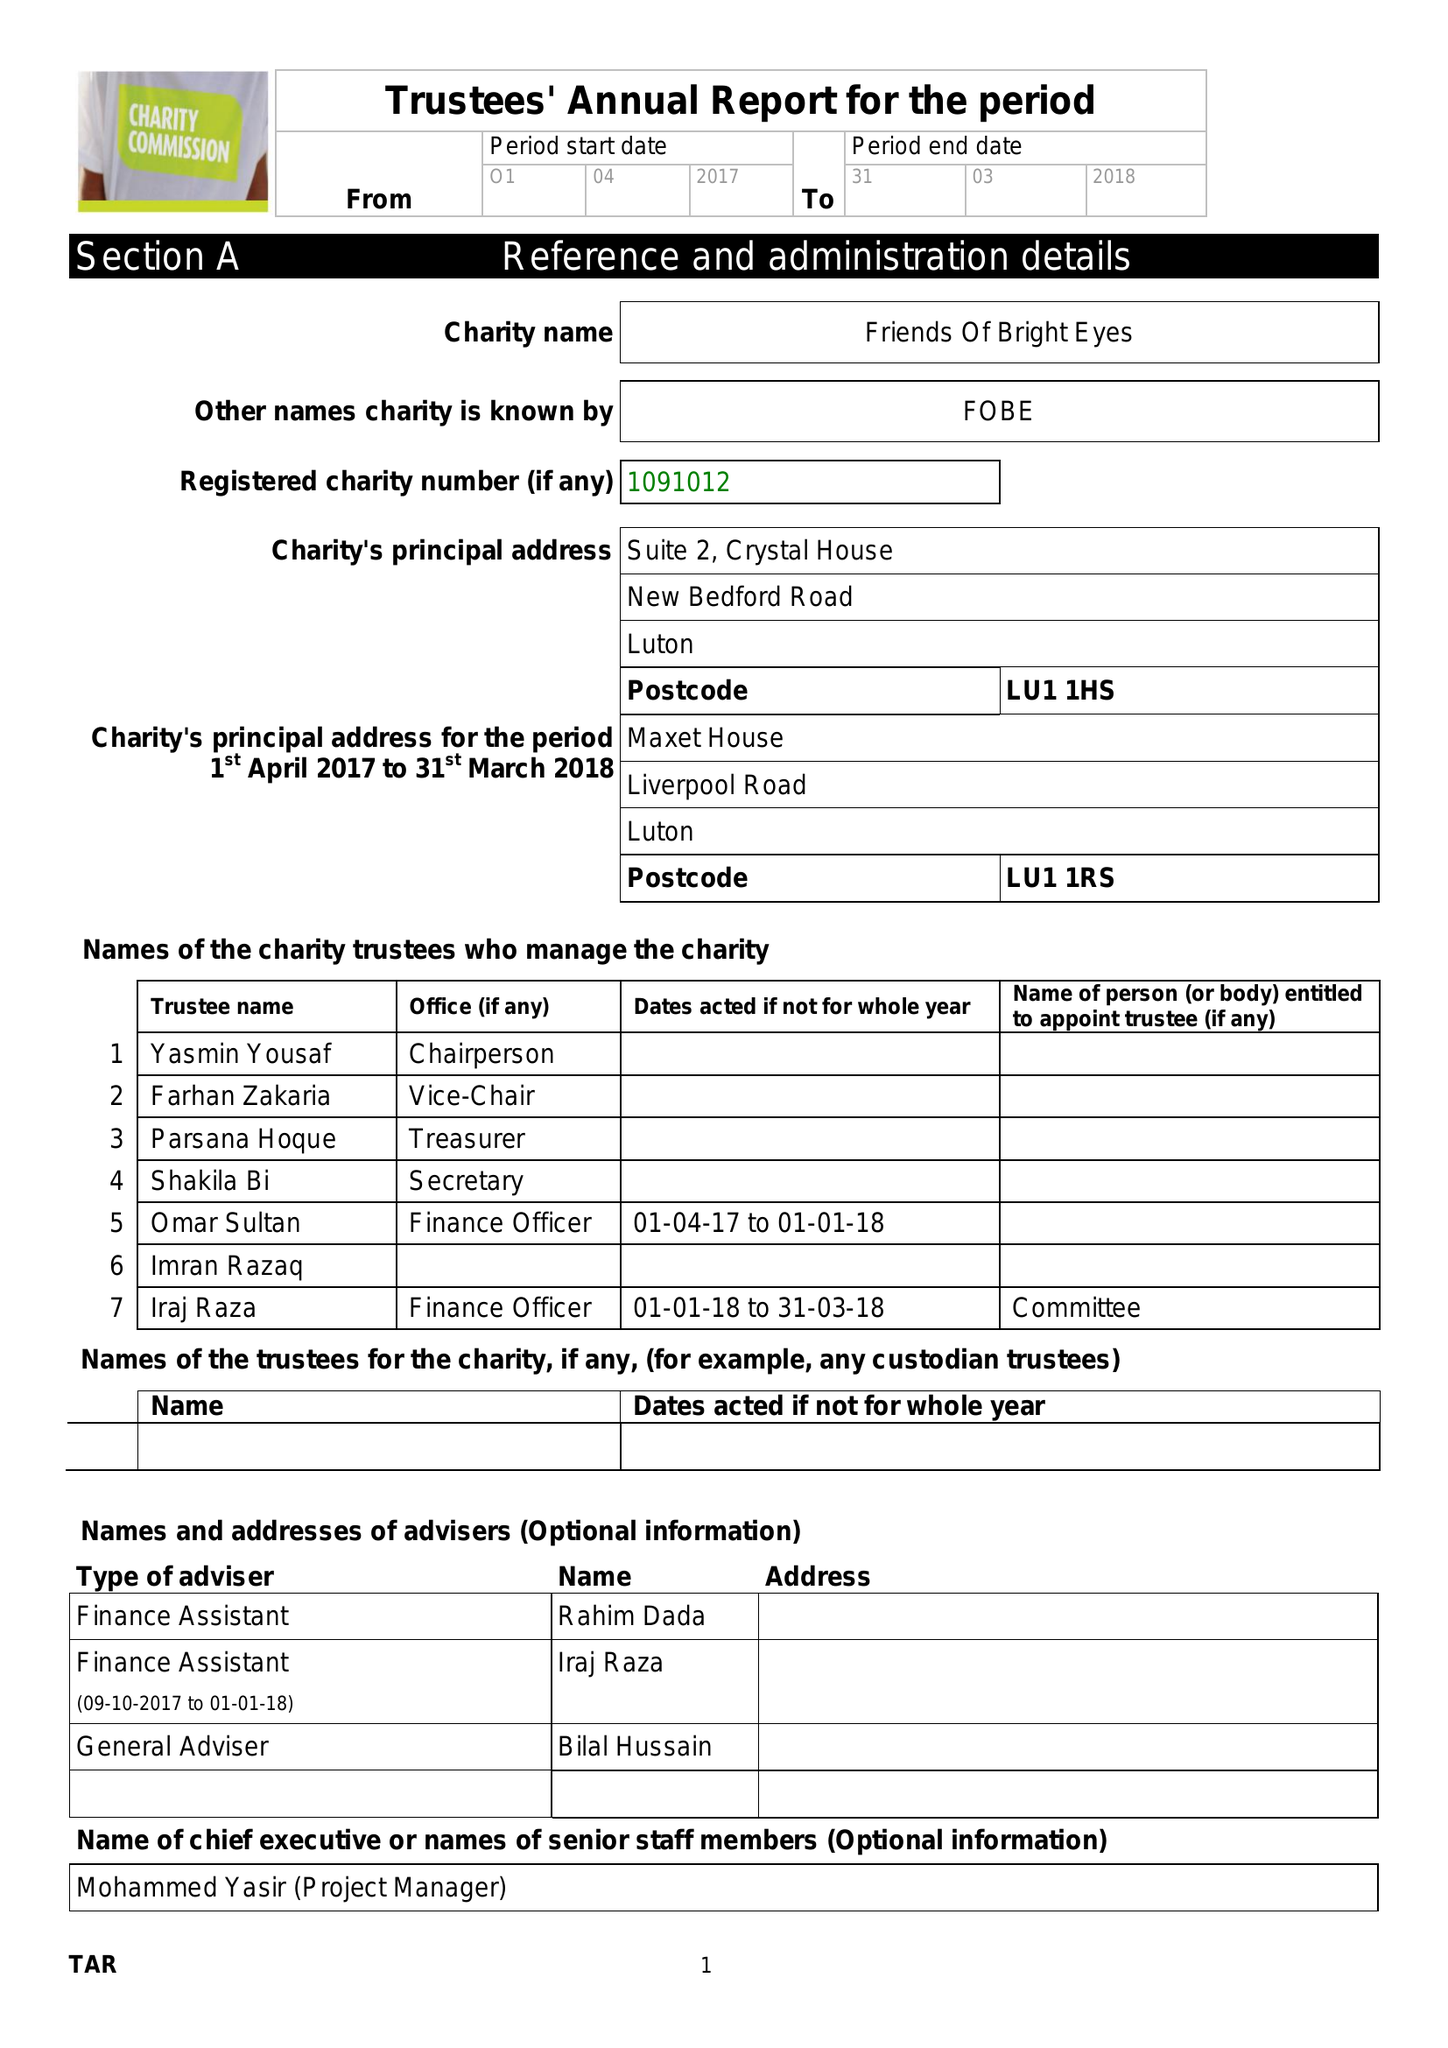What is the value for the spending_annually_in_british_pounds?
Answer the question using a single word or phrase. 101958.00 